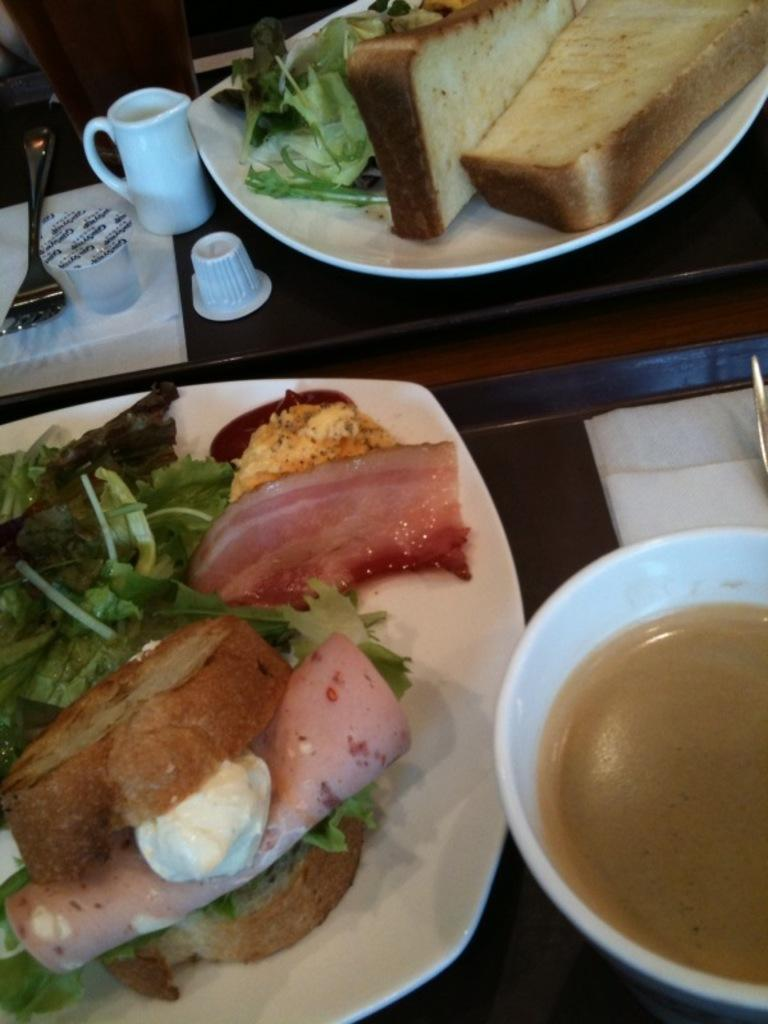What is on the plates and bowl in the image? There are plates with food and a bowl with food in the image. Where are the plates and bowl located? The plates and bowl are placed on a table. What else can be seen on the table? There are cups and a fork in the image. What is beside the cups and fork? There are papers beside the cups and fork. Where is the jail located in the image? There is no jail present in the image. What type of nest can be seen in the image? There is no nest present in the image. 